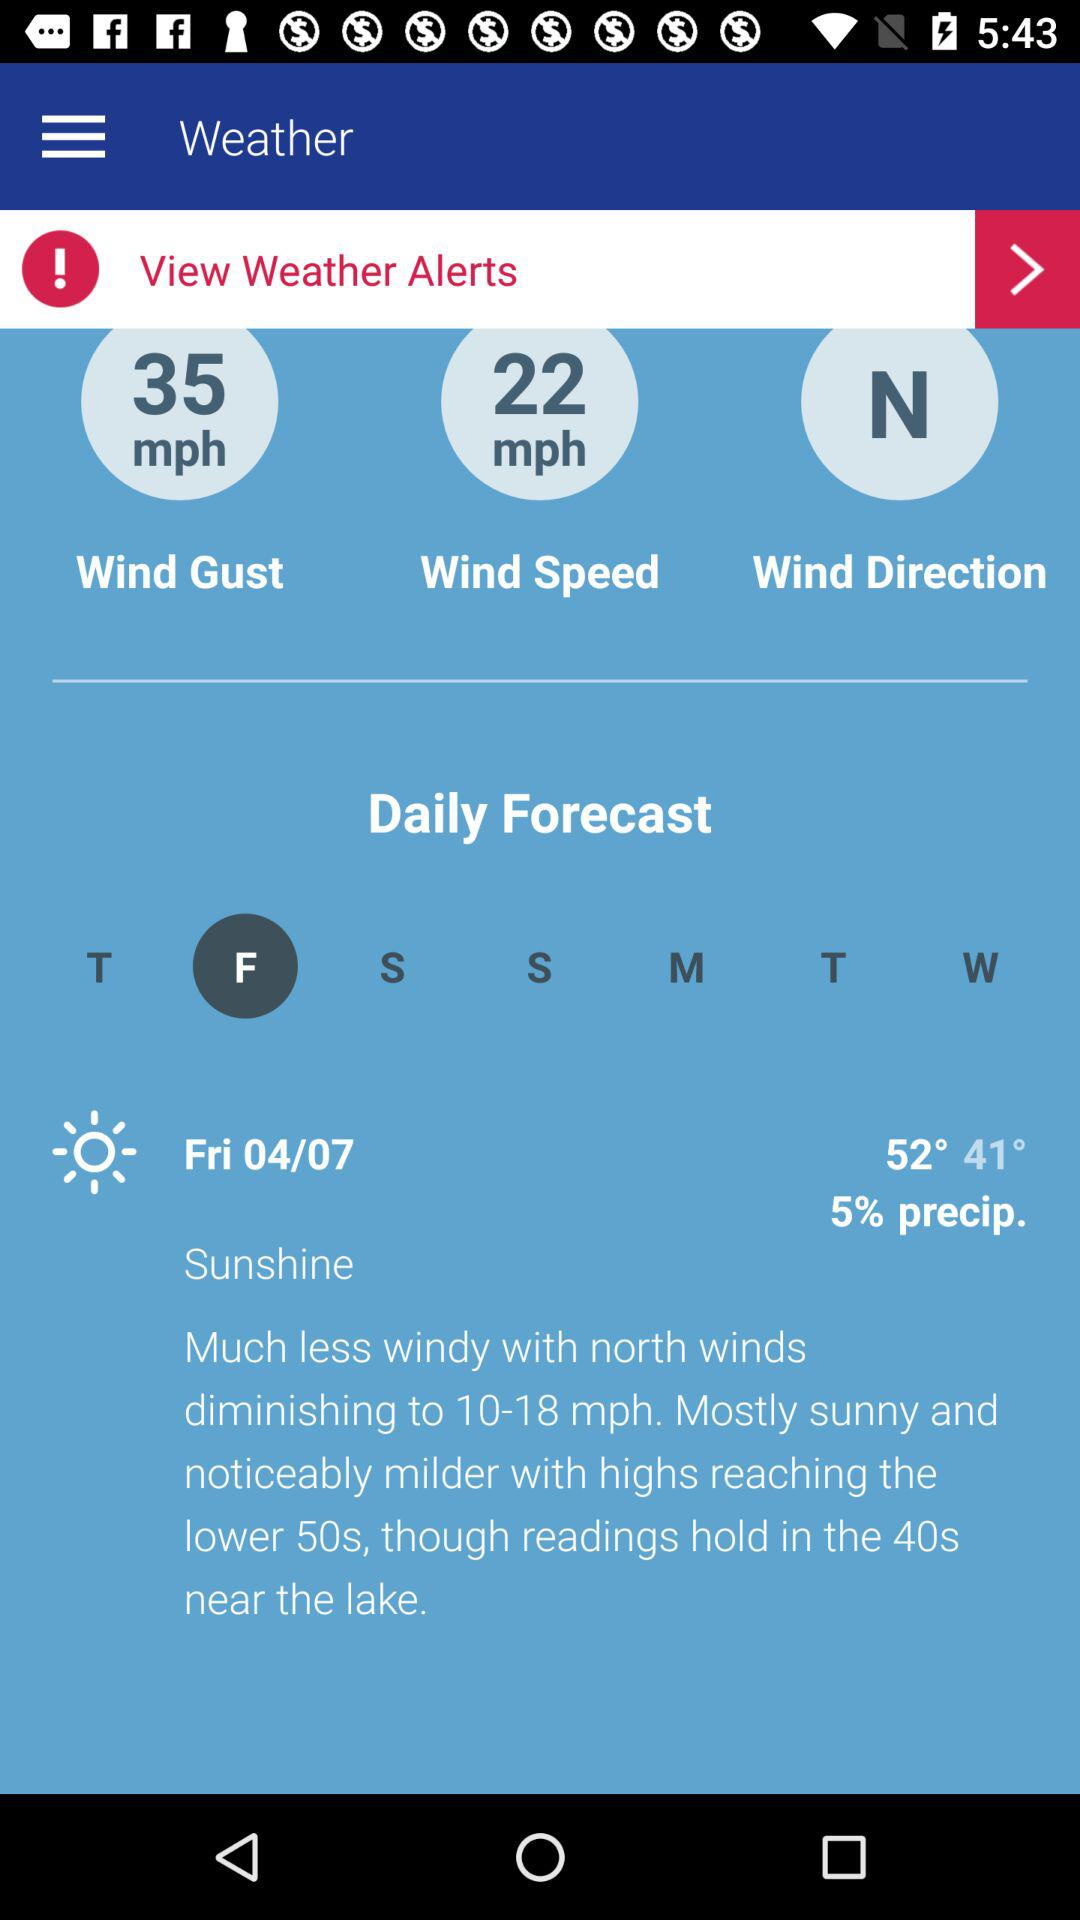What is the measured value of the wind speed? The measured value of the wind speed is 22 mph. 